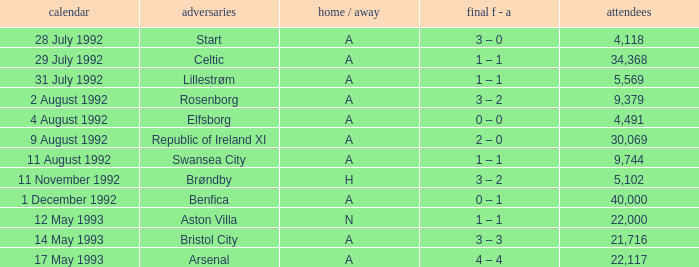Would you be able to parse every entry in this table? {'header': ['calendar', 'adversaries', 'home / away', 'final f - a', 'attendees'], 'rows': [['28 July 1992', 'Start', 'A', '3 – 0', '4,118'], ['29 July 1992', 'Celtic', 'A', '1 – 1', '34,368'], ['31 July 1992', 'Lillestrøm', 'A', '1 – 1', '5,569'], ['2 August 1992', 'Rosenborg', 'A', '3 – 2', '9,379'], ['4 August 1992', 'Elfsborg', 'A', '0 – 0', '4,491'], ['9 August 1992', 'Republic of Ireland XI', 'A', '2 – 0', '30,069'], ['11 August 1992', 'Swansea City', 'A', '1 – 1', '9,744'], ['11 November 1992', 'Brøndby', 'H', '3 – 2', '5,102'], ['1 December 1992', 'Benfica', 'A', '0 – 1', '40,000'], ['12 May 1993', 'Aston Villa', 'N', '1 – 1', '22,000'], ['14 May 1993', 'Bristol City', 'A', '3 – 3', '21,716'], ['17 May 1993', 'Arsenal', 'A', '4 – 4', '22,117']]} Which Result F-A has Opponents of rosenborg? 3 – 2. 